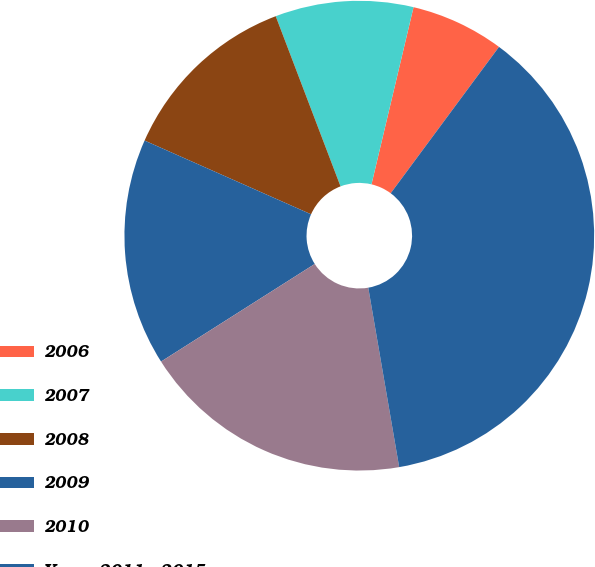<chart> <loc_0><loc_0><loc_500><loc_500><pie_chart><fcel>2006<fcel>2007<fcel>2008<fcel>2009<fcel>2010<fcel>Years 2011 - 2015<nl><fcel>6.43%<fcel>9.5%<fcel>12.57%<fcel>15.64%<fcel>18.71%<fcel>37.14%<nl></chart> 